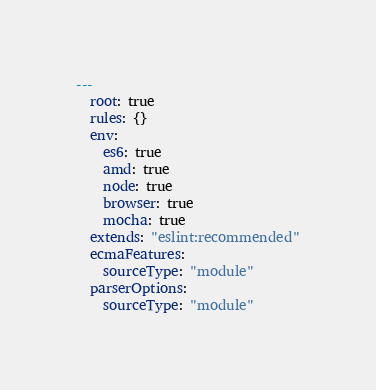<code> <loc_0><loc_0><loc_500><loc_500><_YAML_>---
  root: true
  rules: {}
  env:
    es6: true
    amd: true
    node: true
    browser: true
    mocha: true
  extends: "eslint:recommended"
  ecmaFeatures:
    sourceType: "module"
  parserOptions:
    sourceType: "module"
</code> 